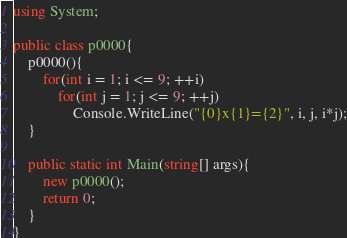<code> <loc_0><loc_0><loc_500><loc_500><_C#_>using System;

public class p0000{
	p0000(){
		for(int i = 1; i <= 9; ++i)
			for(int j = 1; j <= 9; ++j)
				Console.WriteLine("{0}x{1}={2}", i, j, i*j);
	}
	
	public static int Main(string[] args){
		new p0000();
		return 0;
	}
}</code> 